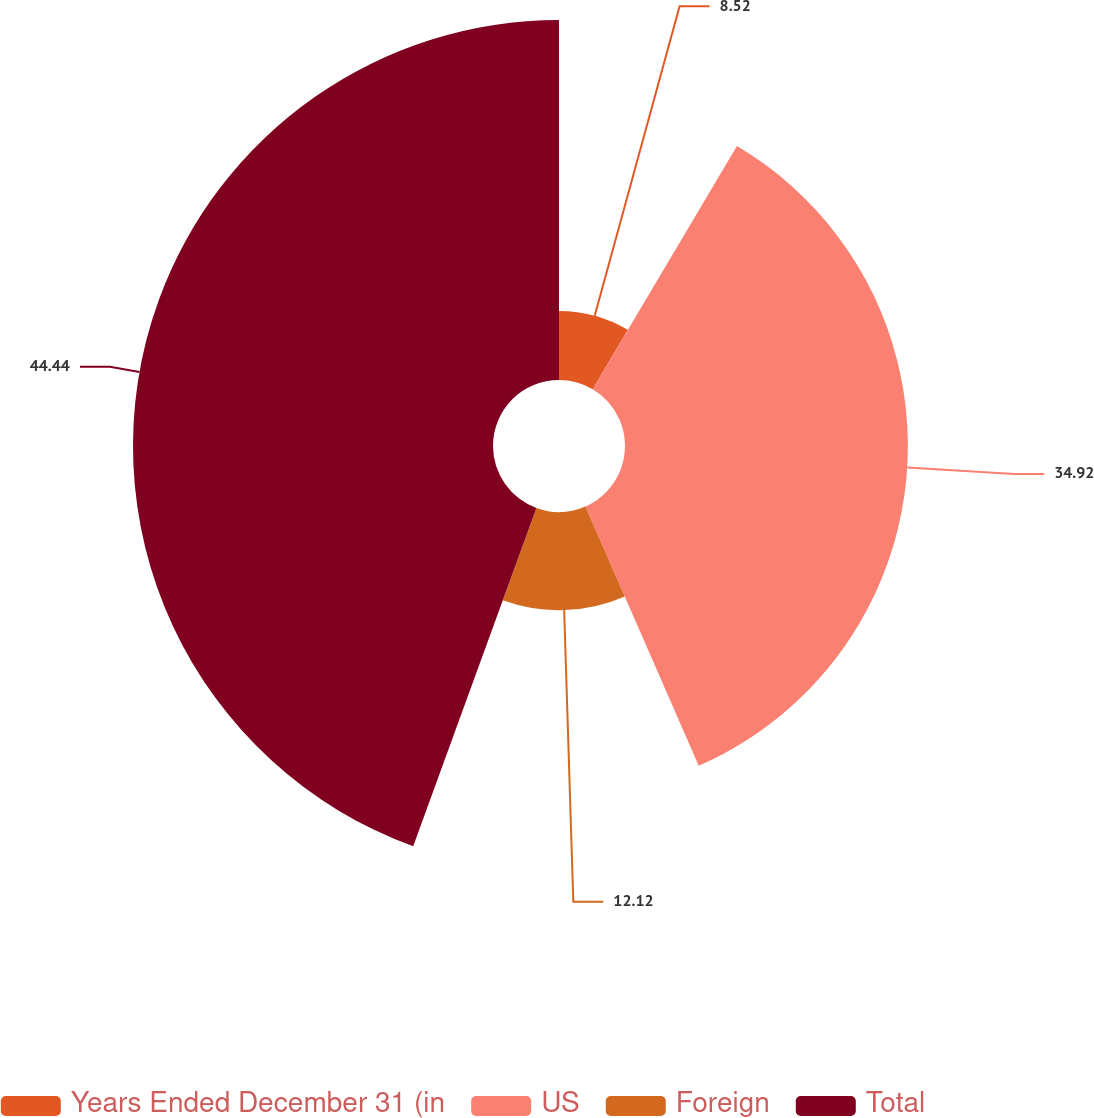Convert chart to OTSL. <chart><loc_0><loc_0><loc_500><loc_500><pie_chart><fcel>Years Ended December 31 (in<fcel>US<fcel>Foreign<fcel>Total<nl><fcel>8.52%<fcel>34.92%<fcel>12.12%<fcel>44.44%<nl></chart> 